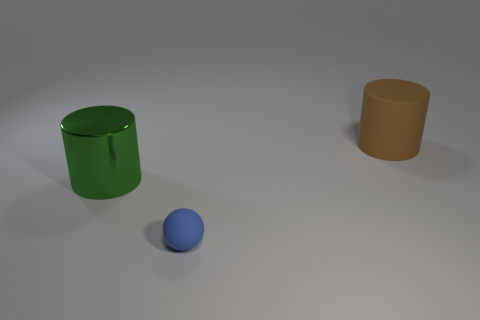Are there any distinctive features or textures on the objects that might suggest their use? The green metallic cylinder has a reflective surface and what appears to be a lid or a slot, suggesting it could be a container or a bin of some sort. The brown cylindrical object, lacking any distinctive features, is perhaps a simple model used for display or educational purposes. The blue sphere has a color and texture that might indicate it is a rubber ball, often used for various games or physical activities. 